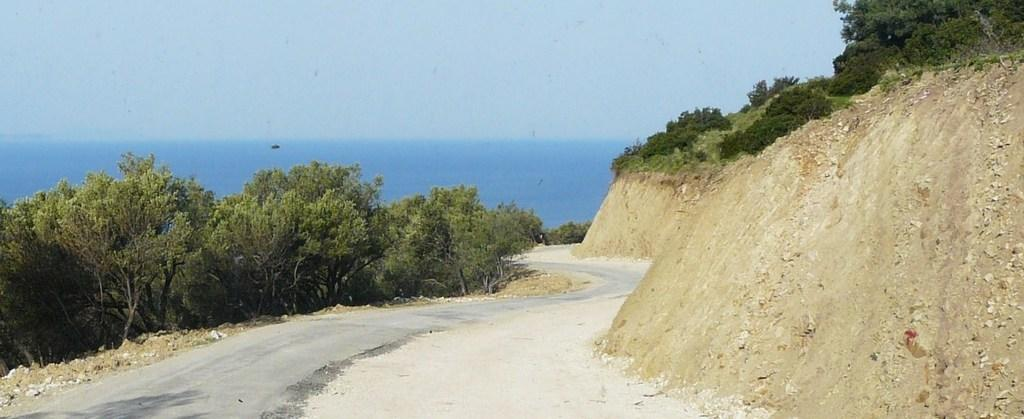What type of pathway is visible in the image? There is a road in the image. What natural elements can be seen in the image? There are trees and a sea in the image. What is the terrain like on the right side of the image? There is sloppy land on the right side of the image. What type of vegetation is present on the sloppy land? There are plants on the sloppy land. What is visible at the top of the image? The sky is visible at the top of the image. Where is the clock located in the image? There is no clock present in the image. What type of carriage can be seen traveling along the road in the image? There is no carriage present in the image. 